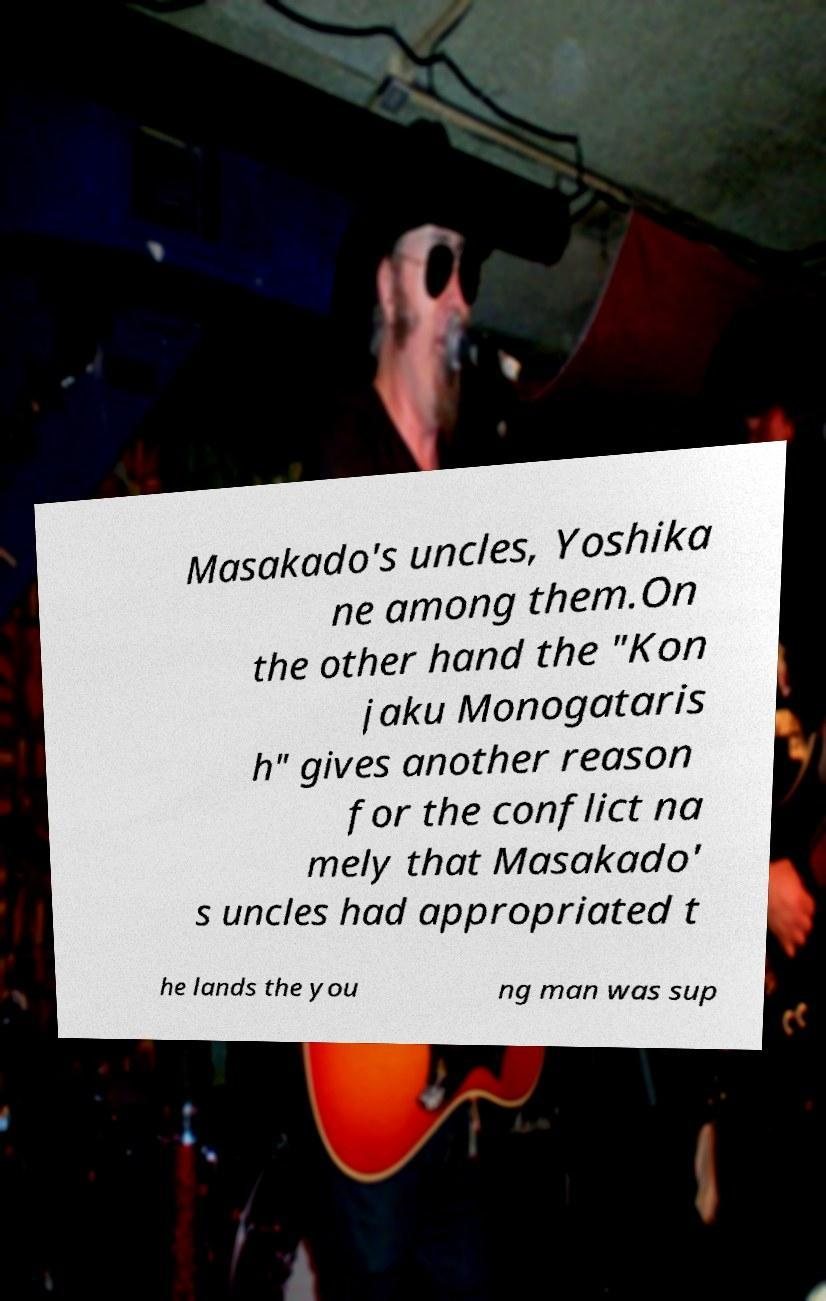Can you accurately transcribe the text from the provided image for me? Masakado's uncles, Yoshika ne among them.On the other hand the "Kon jaku Monogataris h" gives another reason for the conflict na mely that Masakado' s uncles had appropriated t he lands the you ng man was sup 